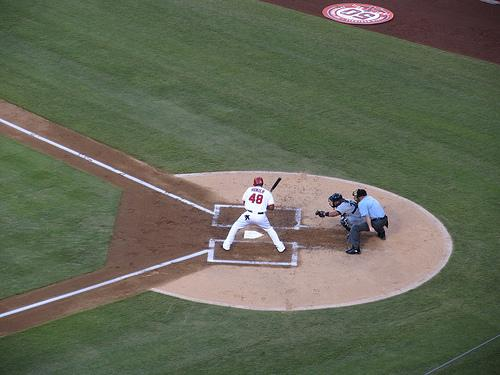What number is on the back of the baseball player's shirt? The number on the back of the baseball player's shirt is 48. Describe the area in the field where the batter, catcher, and umpire are located. The batter, catcher, and umpire are located in the batting area of the field, near the home plate on the baseball diamond. Identify the object that the baseball player is holding in his hand. The baseball player is holding a black baseball bat in his hand. Explain the positions of the batter, catcher, and umpire in relation to the home plate. The batter is standing beside the home plate, ready to swing. The catcher is crouched behind the home plate, prepared to catch the ball, and the umpire is standing near the catcher, watching the play. What is the color of the helmet worn by the batter in the image? The helmet worn by the batter is red. Please provide a brief description of the scene involving the baseball player, catcher, umpire, and home plate. In this scene, a baseball player is up to bat wearing a red helmet and a shirt with number 48. The catcher and umpire are behind him, near the home plate on the field. Mention the two objects worn by the batter in the image. The batter in the image is wearing a red helmet and a shirt with number 48. In which part of the ballpark are the baseball catcher and umpire located? The baseball catcher and umpire are located near the home plate. What is the color and position of the baseball bat in the image? The baseball bat in the image is black and is being held by the batter positioned near the home plate. For a sportswear ad, describe the key sportswear components visible in the image. The sportswear components in the image include a numbered baseball shirt, a red helmet, white pants, gloves, and shoes worn by the baseball player, catcher, and umpire. 